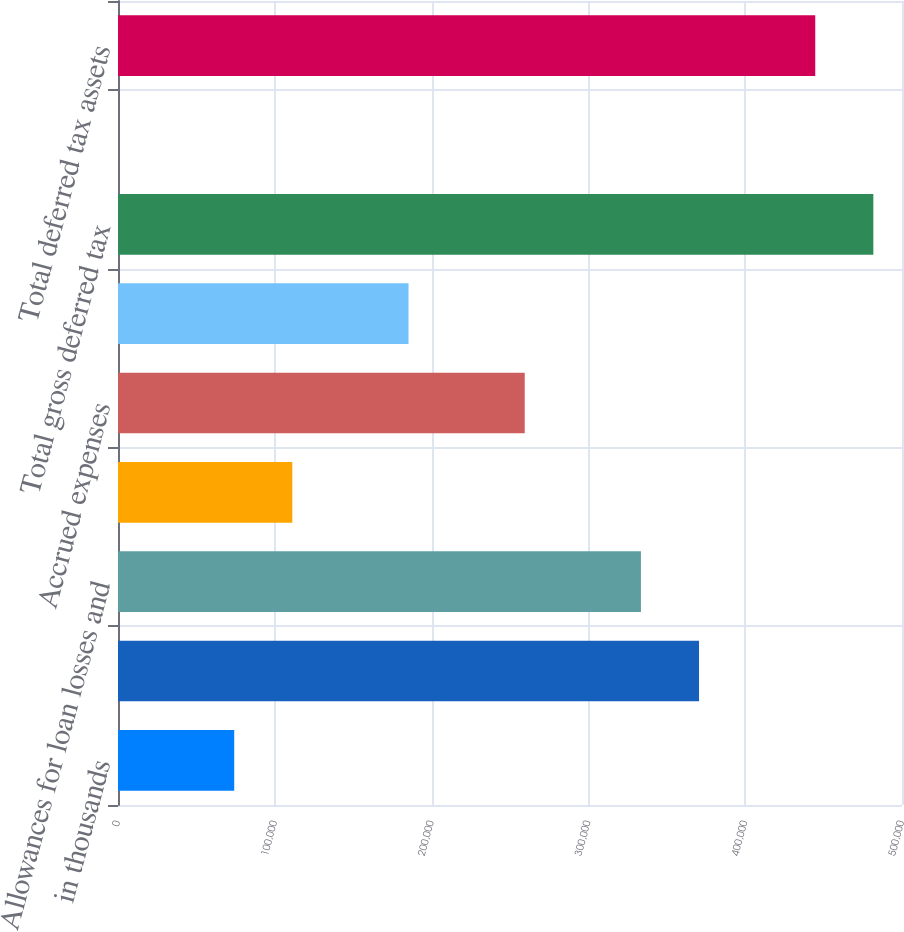<chart> <loc_0><loc_0><loc_500><loc_500><bar_chart><fcel>in thousands<fcel>Deferred compensation<fcel>Allowances for loan losses and<fcel>Unrealized loss associated<fcel>Accrued expenses<fcel>Other<fcel>Total gross deferred tax<fcel>Less valuation allowance<fcel>Total deferred tax assets<nl><fcel>74119.2<fcel>370560<fcel>333505<fcel>111174<fcel>259395<fcel>185284<fcel>481725<fcel>9<fcel>444670<nl></chart> 